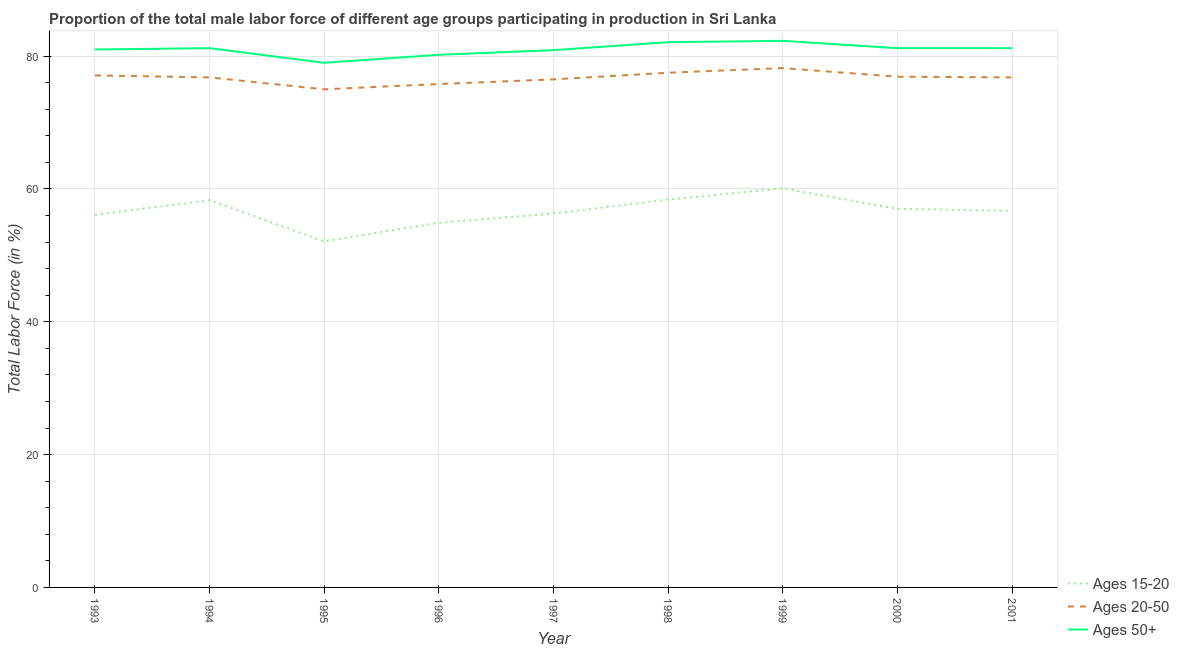Is the number of lines equal to the number of legend labels?
Give a very brief answer. Yes. What is the percentage of male labor force above age 50 in 1999?
Give a very brief answer. 82.3. Across all years, what is the maximum percentage of male labor force above age 50?
Make the answer very short. 82.3. Across all years, what is the minimum percentage of male labor force above age 50?
Offer a terse response. 79. In which year was the percentage of male labor force within the age group 20-50 minimum?
Your answer should be compact. 1995. What is the total percentage of male labor force above age 50 in the graph?
Your answer should be compact. 729.1. What is the difference between the percentage of male labor force within the age group 15-20 in 1998 and that in 2000?
Offer a terse response. 1.4. What is the difference between the percentage of male labor force within the age group 15-20 in 2001 and the percentage of male labor force above age 50 in 1993?
Provide a succinct answer. -24.3. What is the average percentage of male labor force within the age group 15-20 per year?
Your answer should be compact. 56.66. In the year 2001, what is the difference between the percentage of male labor force above age 50 and percentage of male labor force within the age group 20-50?
Make the answer very short. 4.4. In how many years, is the percentage of male labor force within the age group 15-20 greater than 20 %?
Provide a short and direct response. 9. What is the ratio of the percentage of male labor force within the age group 20-50 in 1993 to that in 1997?
Make the answer very short. 1.01. Is the difference between the percentage of male labor force within the age group 20-50 in 1998 and 2001 greater than the difference between the percentage of male labor force within the age group 15-20 in 1998 and 2001?
Make the answer very short. No. What is the difference between the highest and the second highest percentage of male labor force within the age group 15-20?
Give a very brief answer. 1.7. What is the difference between the highest and the lowest percentage of male labor force above age 50?
Make the answer very short. 3.3. Is the percentage of male labor force above age 50 strictly greater than the percentage of male labor force within the age group 20-50 over the years?
Keep it short and to the point. Yes. What is the difference between two consecutive major ticks on the Y-axis?
Give a very brief answer. 20. Are the values on the major ticks of Y-axis written in scientific E-notation?
Offer a very short reply. No. Does the graph contain any zero values?
Keep it short and to the point. No. Does the graph contain grids?
Give a very brief answer. Yes. How are the legend labels stacked?
Provide a succinct answer. Vertical. What is the title of the graph?
Provide a short and direct response. Proportion of the total male labor force of different age groups participating in production in Sri Lanka. What is the label or title of the X-axis?
Keep it short and to the point. Year. What is the label or title of the Y-axis?
Provide a succinct answer. Total Labor Force (in %). What is the Total Labor Force (in %) of Ages 15-20 in 1993?
Provide a short and direct response. 56.1. What is the Total Labor Force (in %) in Ages 20-50 in 1993?
Offer a terse response. 77.1. What is the Total Labor Force (in %) of Ages 50+ in 1993?
Offer a very short reply. 81. What is the Total Labor Force (in %) in Ages 15-20 in 1994?
Offer a very short reply. 58.3. What is the Total Labor Force (in %) of Ages 20-50 in 1994?
Offer a very short reply. 76.8. What is the Total Labor Force (in %) in Ages 50+ in 1994?
Give a very brief answer. 81.2. What is the Total Labor Force (in %) of Ages 15-20 in 1995?
Give a very brief answer. 52.1. What is the Total Labor Force (in %) of Ages 20-50 in 1995?
Provide a succinct answer. 75. What is the Total Labor Force (in %) in Ages 50+ in 1995?
Keep it short and to the point. 79. What is the Total Labor Force (in %) of Ages 15-20 in 1996?
Ensure brevity in your answer.  54.9. What is the Total Labor Force (in %) in Ages 20-50 in 1996?
Your answer should be compact. 75.8. What is the Total Labor Force (in %) in Ages 50+ in 1996?
Your answer should be compact. 80.2. What is the Total Labor Force (in %) in Ages 15-20 in 1997?
Offer a terse response. 56.3. What is the Total Labor Force (in %) of Ages 20-50 in 1997?
Keep it short and to the point. 76.5. What is the Total Labor Force (in %) in Ages 50+ in 1997?
Keep it short and to the point. 80.9. What is the Total Labor Force (in %) of Ages 15-20 in 1998?
Make the answer very short. 58.4. What is the Total Labor Force (in %) in Ages 20-50 in 1998?
Give a very brief answer. 77.5. What is the Total Labor Force (in %) of Ages 50+ in 1998?
Ensure brevity in your answer.  82.1. What is the Total Labor Force (in %) in Ages 15-20 in 1999?
Ensure brevity in your answer.  60.1. What is the Total Labor Force (in %) of Ages 20-50 in 1999?
Give a very brief answer. 78.2. What is the Total Labor Force (in %) in Ages 50+ in 1999?
Ensure brevity in your answer.  82.3. What is the Total Labor Force (in %) in Ages 15-20 in 2000?
Your response must be concise. 57. What is the Total Labor Force (in %) of Ages 20-50 in 2000?
Offer a very short reply. 76.9. What is the Total Labor Force (in %) of Ages 50+ in 2000?
Your answer should be very brief. 81.2. What is the Total Labor Force (in %) of Ages 15-20 in 2001?
Offer a terse response. 56.7. What is the Total Labor Force (in %) of Ages 20-50 in 2001?
Give a very brief answer. 76.8. What is the Total Labor Force (in %) in Ages 50+ in 2001?
Your answer should be very brief. 81.2. Across all years, what is the maximum Total Labor Force (in %) in Ages 15-20?
Make the answer very short. 60.1. Across all years, what is the maximum Total Labor Force (in %) of Ages 20-50?
Keep it short and to the point. 78.2. Across all years, what is the maximum Total Labor Force (in %) in Ages 50+?
Your response must be concise. 82.3. Across all years, what is the minimum Total Labor Force (in %) in Ages 15-20?
Offer a very short reply. 52.1. Across all years, what is the minimum Total Labor Force (in %) of Ages 20-50?
Keep it short and to the point. 75. Across all years, what is the minimum Total Labor Force (in %) in Ages 50+?
Keep it short and to the point. 79. What is the total Total Labor Force (in %) of Ages 15-20 in the graph?
Make the answer very short. 509.9. What is the total Total Labor Force (in %) of Ages 20-50 in the graph?
Offer a terse response. 690.6. What is the total Total Labor Force (in %) of Ages 50+ in the graph?
Make the answer very short. 729.1. What is the difference between the Total Labor Force (in %) of Ages 15-20 in 1993 and that in 1994?
Provide a succinct answer. -2.2. What is the difference between the Total Labor Force (in %) in Ages 20-50 in 1993 and that in 1994?
Make the answer very short. 0.3. What is the difference between the Total Labor Force (in %) of Ages 50+ in 1993 and that in 1994?
Offer a very short reply. -0.2. What is the difference between the Total Labor Force (in %) of Ages 50+ in 1993 and that in 1995?
Offer a terse response. 2. What is the difference between the Total Labor Force (in %) of Ages 15-20 in 1993 and that in 1996?
Provide a succinct answer. 1.2. What is the difference between the Total Labor Force (in %) of Ages 20-50 in 1993 and that in 1996?
Give a very brief answer. 1.3. What is the difference between the Total Labor Force (in %) of Ages 50+ in 1993 and that in 1996?
Your answer should be compact. 0.8. What is the difference between the Total Labor Force (in %) of Ages 15-20 in 1993 and that in 1997?
Make the answer very short. -0.2. What is the difference between the Total Labor Force (in %) of Ages 20-50 in 1993 and that in 1997?
Keep it short and to the point. 0.6. What is the difference between the Total Labor Force (in %) of Ages 50+ in 1993 and that in 1998?
Keep it short and to the point. -1.1. What is the difference between the Total Labor Force (in %) in Ages 50+ in 1993 and that in 1999?
Your answer should be compact. -1.3. What is the difference between the Total Labor Force (in %) of Ages 20-50 in 1993 and that in 2000?
Your response must be concise. 0.2. What is the difference between the Total Labor Force (in %) of Ages 50+ in 1993 and that in 2000?
Offer a terse response. -0.2. What is the difference between the Total Labor Force (in %) in Ages 15-20 in 1993 and that in 2001?
Offer a very short reply. -0.6. What is the difference between the Total Labor Force (in %) of Ages 20-50 in 1993 and that in 2001?
Provide a succinct answer. 0.3. What is the difference between the Total Labor Force (in %) in Ages 20-50 in 1994 and that in 1995?
Your answer should be compact. 1.8. What is the difference between the Total Labor Force (in %) in Ages 50+ in 1994 and that in 1995?
Provide a short and direct response. 2.2. What is the difference between the Total Labor Force (in %) of Ages 15-20 in 1994 and that in 1996?
Make the answer very short. 3.4. What is the difference between the Total Labor Force (in %) in Ages 50+ in 1994 and that in 1996?
Your answer should be very brief. 1. What is the difference between the Total Labor Force (in %) in Ages 15-20 in 1994 and that in 1997?
Your answer should be very brief. 2. What is the difference between the Total Labor Force (in %) of Ages 20-50 in 1994 and that in 1997?
Ensure brevity in your answer.  0.3. What is the difference between the Total Labor Force (in %) of Ages 15-20 in 1994 and that in 1998?
Your answer should be very brief. -0.1. What is the difference between the Total Labor Force (in %) in Ages 20-50 in 1994 and that in 1998?
Offer a very short reply. -0.7. What is the difference between the Total Labor Force (in %) in Ages 50+ in 1994 and that in 1998?
Keep it short and to the point. -0.9. What is the difference between the Total Labor Force (in %) of Ages 50+ in 1994 and that in 1999?
Offer a terse response. -1.1. What is the difference between the Total Labor Force (in %) of Ages 20-50 in 1994 and that in 2000?
Your answer should be compact. -0.1. What is the difference between the Total Labor Force (in %) of Ages 50+ in 1994 and that in 2000?
Offer a terse response. 0. What is the difference between the Total Labor Force (in %) of Ages 20-50 in 1994 and that in 2001?
Offer a terse response. 0. What is the difference between the Total Labor Force (in %) of Ages 50+ in 1994 and that in 2001?
Ensure brevity in your answer.  0. What is the difference between the Total Labor Force (in %) in Ages 20-50 in 1995 and that in 1996?
Your answer should be very brief. -0.8. What is the difference between the Total Labor Force (in %) in Ages 50+ in 1995 and that in 1996?
Your answer should be very brief. -1.2. What is the difference between the Total Labor Force (in %) of Ages 15-20 in 1995 and that in 1997?
Provide a short and direct response. -4.2. What is the difference between the Total Labor Force (in %) in Ages 50+ in 1995 and that in 1997?
Offer a terse response. -1.9. What is the difference between the Total Labor Force (in %) in Ages 15-20 in 1995 and that in 1998?
Offer a terse response. -6.3. What is the difference between the Total Labor Force (in %) of Ages 50+ in 1995 and that in 1998?
Your answer should be very brief. -3.1. What is the difference between the Total Labor Force (in %) in Ages 15-20 in 1995 and that in 1999?
Give a very brief answer. -8. What is the difference between the Total Labor Force (in %) of Ages 20-50 in 1995 and that in 1999?
Make the answer very short. -3.2. What is the difference between the Total Labor Force (in %) of Ages 50+ in 1995 and that in 1999?
Offer a very short reply. -3.3. What is the difference between the Total Labor Force (in %) in Ages 15-20 in 1995 and that in 2000?
Ensure brevity in your answer.  -4.9. What is the difference between the Total Labor Force (in %) in Ages 20-50 in 1995 and that in 2000?
Make the answer very short. -1.9. What is the difference between the Total Labor Force (in %) in Ages 20-50 in 1995 and that in 2001?
Ensure brevity in your answer.  -1.8. What is the difference between the Total Labor Force (in %) in Ages 50+ in 1995 and that in 2001?
Provide a short and direct response. -2.2. What is the difference between the Total Labor Force (in %) of Ages 15-20 in 1996 and that in 1997?
Your answer should be compact. -1.4. What is the difference between the Total Labor Force (in %) in Ages 50+ in 1996 and that in 1997?
Provide a short and direct response. -0.7. What is the difference between the Total Labor Force (in %) of Ages 15-20 in 1996 and that in 1998?
Offer a terse response. -3.5. What is the difference between the Total Labor Force (in %) in Ages 20-50 in 1996 and that in 1998?
Your answer should be compact. -1.7. What is the difference between the Total Labor Force (in %) in Ages 20-50 in 1996 and that in 1999?
Provide a short and direct response. -2.4. What is the difference between the Total Labor Force (in %) of Ages 15-20 in 1996 and that in 2000?
Provide a short and direct response. -2.1. What is the difference between the Total Labor Force (in %) in Ages 15-20 in 1996 and that in 2001?
Your response must be concise. -1.8. What is the difference between the Total Labor Force (in %) of Ages 50+ in 1996 and that in 2001?
Provide a short and direct response. -1. What is the difference between the Total Labor Force (in %) in Ages 50+ in 1997 and that in 1998?
Ensure brevity in your answer.  -1.2. What is the difference between the Total Labor Force (in %) of Ages 20-50 in 1997 and that in 1999?
Your answer should be compact. -1.7. What is the difference between the Total Labor Force (in %) of Ages 50+ in 1997 and that in 1999?
Ensure brevity in your answer.  -1.4. What is the difference between the Total Labor Force (in %) in Ages 20-50 in 1998 and that in 1999?
Your answer should be compact. -0.7. What is the difference between the Total Labor Force (in %) of Ages 50+ in 1998 and that in 2000?
Offer a very short reply. 0.9. What is the difference between the Total Labor Force (in %) in Ages 15-20 in 1998 and that in 2001?
Provide a succinct answer. 1.7. What is the difference between the Total Labor Force (in %) in Ages 20-50 in 1998 and that in 2001?
Offer a very short reply. 0.7. What is the difference between the Total Labor Force (in %) in Ages 50+ in 1998 and that in 2001?
Your response must be concise. 0.9. What is the difference between the Total Labor Force (in %) in Ages 15-20 in 1999 and that in 2000?
Your answer should be very brief. 3.1. What is the difference between the Total Labor Force (in %) of Ages 20-50 in 1999 and that in 2000?
Your answer should be very brief. 1.3. What is the difference between the Total Labor Force (in %) in Ages 15-20 in 1999 and that in 2001?
Keep it short and to the point. 3.4. What is the difference between the Total Labor Force (in %) of Ages 50+ in 1999 and that in 2001?
Your answer should be very brief. 1.1. What is the difference between the Total Labor Force (in %) in Ages 15-20 in 2000 and that in 2001?
Ensure brevity in your answer.  0.3. What is the difference between the Total Labor Force (in %) in Ages 15-20 in 1993 and the Total Labor Force (in %) in Ages 20-50 in 1994?
Provide a succinct answer. -20.7. What is the difference between the Total Labor Force (in %) in Ages 15-20 in 1993 and the Total Labor Force (in %) in Ages 50+ in 1994?
Your response must be concise. -25.1. What is the difference between the Total Labor Force (in %) in Ages 20-50 in 1993 and the Total Labor Force (in %) in Ages 50+ in 1994?
Your response must be concise. -4.1. What is the difference between the Total Labor Force (in %) of Ages 15-20 in 1993 and the Total Labor Force (in %) of Ages 20-50 in 1995?
Your answer should be compact. -18.9. What is the difference between the Total Labor Force (in %) in Ages 15-20 in 1993 and the Total Labor Force (in %) in Ages 50+ in 1995?
Keep it short and to the point. -22.9. What is the difference between the Total Labor Force (in %) of Ages 20-50 in 1993 and the Total Labor Force (in %) of Ages 50+ in 1995?
Your answer should be compact. -1.9. What is the difference between the Total Labor Force (in %) in Ages 15-20 in 1993 and the Total Labor Force (in %) in Ages 20-50 in 1996?
Your answer should be very brief. -19.7. What is the difference between the Total Labor Force (in %) of Ages 15-20 in 1993 and the Total Labor Force (in %) of Ages 50+ in 1996?
Offer a terse response. -24.1. What is the difference between the Total Labor Force (in %) in Ages 15-20 in 1993 and the Total Labor Force (in %) in Ages 20-50 in 1997?
Provide a succinct answer. -20.4. What is the difference between the Total Labor Force (in %) in Ages 15-20 in 1993 and the Total Labor Force (in %) in Ages 50+ in 1997?
Provide a succinct answer. -24.8. What is the difference between the Total Labor Force (in %) of Ages 20-50 in 1993 and the Total Labor Force (in %) of Ages 50+ in 1997?
Offer a terse response. -3.8. What is the difference between the Total Labor Force (in %) in Ages 15-20 in 1993 and the Total Labor Force (in %) in Ages 20-50 in 1998?
Provide a short and direct response. -21.4. What is the difference between the Total Labor Force (in %) in Ages 20-50 in 1993 and the Total Labor Force (in %) in Ages 50+ in 1998?
Your answer should be compact. -5. What is the difference between the Total Labor Force (in %) of Ages 15-20 in 1993 and the Total Labor Force (in %) of Ages 20-50 in 1999?
Provide a succinct answer. -22.1. What is the difference between the Total Labor Force (in %) in Ages 15-20 in 1993 and the Total Labor Force (in %) in Ages 50+ in 1999?
Keep it short and to the point. -26.2. What is the difference between the Total Labor Force (in %) in Ages 15-20 in 1993 and the Total Labor Force (in %) in Ages 20-50 in 2000?
Ensure brevity in your answer.  -20.8. What is the difference between the Total Labor Force (in %) in Ages 15-20 in 1993 and the Total Labor Force (in %) in Ages 50+ in 2000?
Offer a terse response. -25.1. What is the difference between the Total Labor Force (in %) in Ages 20-50 in 1993 and the Total Labor Force (in %) in Ages 50+ in 2000?
Keep it short and to the point. -4.1. What is the difference between the Total Labor Force (in %) in Ages 15-20 in 1993 and the Total Labor Force (in %) in Ages 20-50 in 2001?
Your response must be concise. -20.7. What is the difference between the Total Labor Force (in %) in Ages 15-20 in 1993 and the Total Labor Force (in %) in Ages 50+ in 2001?
Offer a terse response. -25.1. What is the difference between the Total Labor Force (in %) in Ages 20-50 in 1993 and the Total Labor Force (in %) in Ages 50+ in 2001?
Your response must be concise. -4.1. What is the difference between the Total Labor Force (in %) of Ages 15-20 in 1994 and the Total Labor Force (in %) of Ages 20-50 in 1995?
Give a very brief answer. -16.7. What is the difference between the Total Labor Force (in %) in Ages 15-20 in 1994 and the Total Labor Force (in %) in Ages 50+ in 1995?
Provide a short and direct response. -20.7. What is the difference between the Total Labor Force (in %) in Ages 20-50 in 1994 and the Total Labor Force (in %) in Ages 50+ in 1995?
Offer a terse response. -2.2. What is the difference between the Total Labor Force (in %) in Ages 15-20 in 1994 and the Total Labor Force (in %) in Ages 20-50 in 1996?
Provide a succinct answer. -17.5. What is the difference between the Total Labor Force (in %) of Ages 15-20 in 1994 and the Total Labor Force (in %) of Ages 50+ in 1996?
Ensure brevity in your answer.  -21.9. What is the difference between the Total Labor Force (in %) in Ages 15-20 in 1994 and the Total Labor Force (in %) in Ages 20-50 in 1997?
Keep it short and to the point. -18.2. What is the difference between the Total Labor Force (in %) in Ages 15-20 in 1994 and the Total Labor Force (in %) in Ages 50+ in 1997?
Give a very brief answer. -22.6. What is the difference between the Total Labor Force (in %) of Ages 15-20 in 1994 and the Total Labor Force (in %) of Ages 20-50 in 1998?
Ensure brevity in your answer.  -19.2. What is the difference between the Total Labor Force (in %) of Ages 15-20 in 1994 and the Total Labor Force (in %) of Ages 50+ in 1998?
Offer a very short reply. -23.8. What is the difference between the Total Labor Force (in %) of Ages 15-20 in 1994 and the Total Labor Force (in %) of Ages 20-50 in 1999?
Give a very brief answer. -19.9. What is the difference between the Total Labor Force (in %) in Ages 15-20 in 1994 and the Total Labor Force (in %) in Ages 50+ in 1999?
Give a very brief answer. -24. What is the difference between the Total Labor Force (in %) of Ages 20-50 in 1994 and the Total Labor Force (in %) of Ages 50+ in 1999?
Offer a very short reply. -5.5. What is the difference between the Total Labor Force (in %) of Ages 15-20 in 1994 and the Total Labor Force (in %) of Ages 20-50 in 2000?
Offer a very short reply. -18.6. What is the difference between the Total Labor Force (in %) in Ages 15-20 in 1994 and the Total Labor Force (in %) in Ages 50+ in 2000?
Keep it short and to the point. -22.9. What is the difference between the Total Labor Force (in %) of Ages 15-20 in 1994 and the Total Labor Force (in %) of Ages 20-50 in 2001?
Keep it short and to the point. -18.5. What is the difference between the Total Labor Force (in %) in Ages 15-20 in 1994 and the Total Labor Force (in %) in Ages 50+ in 2001?
Offer a terse response. -22.9. What is the difference between the Total Labor Force (in %) in Ages 15-20 in 1995 and the Total Labor Force (in %) in Ages 20-50 in 1996?
Offer a very short reply. -23.7. What is the difference between the Total Labor Force (in %) in Ages 15-20 in 1995 and the Total Labor Force (in %) in Ages 50+ in 1996?
Your answer should be compact. -28.1. What is the difference between the Total Labor Force (in %) of Ages 15-20 in 1995 and the Total Labor Force (in %) of Ages 20-50 in 1997?
Your answer should be compact. -24.4. What is the difference between the Total Labor Force (in %) of Ages 15-20 in 1995 and the Total Labor Force (in %) of Ages 50+ in 1997?
Offer a terse response. -28.8. What is the difference between the Total Labor Force (in %) of Ages 15-20 in 1995 and the Total Labor Force (in %) of Ages 20-50 in 1998?
Your answer should be very brief. -25.4. What is the difference between the Total Labor Force (in %) in Ages 20-50 in 1995 and the Total Labor Force (in %) in Ages 50+ in 1998?
Your answer should be compact. -7.1. What is the difference between the Total Labor Force (in %) of Ages 15-20 in 1995 and the Total Labor Force (in %) of Ages 20-50 in 1999?
Offer a very short reply. -26.1. What is the difference between the Total Labor Force (in %) of Ages 15-20 in 1995 and the Total Labor Force (in %) of Ages 50+ in 1999?
Make the answer very short. -30.2. What is the difference between the Total Labor Force (in %) of Ages 15-20 in 1995 and the Total Labor Force (in %) of Ages 20-50 in 2000?
Offer a very short reply. -24.8. What is the difference between the Total Labor Force (in %) of Ages 15-20 in 1995 and the Total Labor Force (in %) of Ages 50+ in 2000?
Provide a succinct answer. -29.1. What is the difference between the Total Labor Force (in %) in Ages 20-50 in 1995 and the Total Labor Force (in %) in Ages 50+ in 2000?
Your answer should be very brief. -6.2. What is the difference between the Total Labor Force (in %) of Ages 15-20 in 1995 and the Total Labor Force (in %) of Ages 20-50 in 2001?
Give a very brief answer. -24.7. What is the difference between the Total Labor Force (in %) of Ages 15-20 in 1995 and the Total Labor Force (in %) of Ages 50+ in 2001?
Keep it short and to the point. -29.1. What is the difference between the Total Labor Force (in %) in Ages 15-20 in 1996 and the Total Labor Force (in %) in Ages 20-50 in 1997?
Your response must be concise. -21.6. What is the difference between the Total Labor Force (in %) of Ages 20-50 in 1996 and the Total Labor Force (in %) of Ages 50+ in 1997?
Make the answer very short. -5.1. What is the difference between the Total Labor Force (in %) of Ages 15-20 in 1996 and the Total Labor Force (in %) of Ages 20-50 in 1998?
Offer a very short reply. -22.6. What is the difference between the Total Labor Force (in %) in Ages 15-20 in 1996 and the Total Labor Force (in %) in Ages 50+ in 1998?
Your answer should be very brief. -27.2. What is the difference between the Total Labor Force (in %) in Ages 20-50 in 1996 and the Total Labor Force (in %) in Ages 50+ in 1998?
Your response must be concise. -6.3. What is the difference between the Total Labor Force (in %) of Ages 15-20 in 1996 and the Total Labor Force (in %) of Ages 20-50 in 1999?
Keep it short and to the point. -23.3. What is the difference between the Total Labor Force (in %) of Ages 15-20 in 1996 and the Total Labor Force (in %) of Ages 50+ in 1999?
Offer a terse response. -27.4. What is the difference between the Total Labor Force (in %) of Ages 15-20 in 1996 and the Total Labor Force (in %) of Ages 20-50 in 2000?
Offer a terse response. -22. What is the difference between the Total Labor Force (in %) of Ages 15-20 in 1996 and the Total Labor Force (in %) of Ages 50+ in 2000?
Ensure brevity in your answer.  -26.3. What is the difference between the Total Labor Force (in %) in Ages 20-50 in 1996 and the Total Labor Force (in %) in Ages 50+ in 2000?
Your answer should be very brief. -5.4. What is the difference between the Total Labor Force (in %) in Ages 15-20 in 1996 and the Total Labor Force (in %) in Ages 20-50 in 2001?
Ensure brevity in your answer.  -21.9. What is the difference between the Total Labor Force (in %) of Ages 15-20 in 1996 and the Total Labor Force (in %) of Ages 50+ in 2001?
Keep it short and to the point. -26.3. What is the difference between the Total Labor Force (in %) in Ages 15-20 in 1997 and the Total Labor Force (in %) in Ages 20-50 in 1998?
Keep it short and to the point. -21.2. What is the difference between the Total Labor Force (in %) in Ages 15-20 in 1997 and the Total Labor Force (in %) in Ages 50+ in 1998?
Your answer should be very brief. -25.8. What is the difference between the Total Labor Force (in %) of Ages 15-20 in 1997 and the Total Labor Force (in %) of Ages 20-50 in 1999?
Your answer should be very brief. -21.9. What is the difference between the Total Labor Force (in %) of Ages 15-20 in 1997 and the Total Labor Force (in %) of Ages 50+ in 1999?
Ensure brevity in your answer.  -26. What is the difference between the Total Labor Force (in %) of Ages 15-20 in 1997 and the Total Labor Force (in %) of Ages 20-50 in 2000?
Give a very brief answer. -20.6. What is the difference between the Total Labor Force (in %) of Ages 15-20 in 1997 and the Total Labor Force (in %) of Ages 50+ in 2000?
Keep it short and to the point. -24.9. What is the difference between the Total Labor Force (in %) of Ages 15-20 in 1997 and the Total Labor Force (in %) of Ages 20-50 in 2001?
Your answer should be very brief. -20.5. What is the difference between the Total Labor Force (in %) of Ages 15-20 in 1997 and the Total Labor Force (in %) of Ages 50+ in 2001?
Your answer should be compact. -24.9. What is the difference between the Total Labor Force (in %) of Ages 15-20 in 1998 and the Total Labor Force (in %) of Ages 20-50 in 1999?
Make the answer very short. -19.8. What is the difference between the Total Labor Force (in %) in Ages 15-20 in 1998 and the Total Labor Force (in %) in Ages 50+ in 1999?
Ensure brevity in your answer.  -23.9. What is the difference between the Total Labor Force (in %) in Ages 20-50 in 1998 and the Total Labor Force (in %) in Ages 50+ in 1999?
Provide a short and direct response. -4.8. What is the difference between the Total Labor Force (in %) of Ages 15-20 in 1998 and the Total Labor Force (in %) of Ages 20-50 in 2000?
Ensure brevity in your answer.  -18.5. What is the difference between the Total Labor Force (in %) in Ages 15-20 in 1998 and the Total Labor Force (in %) in Ages 50+ in 2000?
Provide a short and direct response. -22.8. What is the difference between the Total Labor Force (in %) of Ages 20-50 in 1998 and the Total Labor Force (in %) of Ages 50+ in 2000?
Your answer should be very brief. -3.7. What is the difference between the Total Labor Force (in %) in Ages 15-20 in 1998 and the Total Labor Force (in %) in Ages 20-50 in 2001?
Keep it short and to the point. -18.4. What is the difference between the Total Labor Force (in %) in Ages 15-20 in 1998 and the Total Labor Force (in %) in Ages 50+ in 2001?
Your answer should be compact. -22.8. What is the difference between the Total Labor Force (in %) of Ages 20-50 in 1998 and the Total Labor Force (in %) of Ages 50+ in 2001?
Make the answer very short. -3.7. What is the difference between the Total Labor Force (in %) in Ages 15-20 in 1999 and the Total Labor Force (in %) in Ages 20-50 in 2000?
Give a very brief answer. -16.8. What is the difference between the Total Labor Force (in %) of Ages 15-20 in 1999 and the Total Labor Force (in %) of Ages 50+ in 2000?
Keep it short and to the point. -21.1. What is the difference between the Total Labor Force (in %) in Ages 20-50 in 1999 and the Total Labor Force (in %) in Ages 50+ in 2000?
Your answer should be compact. -3. What is the difference between the Total Labor Force (in %) in Ages 15-20 in 1999 and the Total Labor Force (in %) in Ages 20-50 in 2001?
Make the answer very short. -16.7. What is the difference between the Total Labor Force (in %) of Ages 15-20 in 1999 and the Total Labor Force (in %) of Ages 50+ in 2001?
Keep it short and to the point. -21.1. What is the difference between the Total Labor Force (in %) in Ages 20-50 in 1999 and the Total Labor Force (in %) in Ages 50+ in 2001?
Give a very brief answer. -3. What is the difference between the Total Labor Force (in %) of Ages 15-20 in 2000 and the Total Labor Force (in %) of Ages 20-50 in 2001?
Your answer should be compact. -19.8. What is the difference between the Total Labor Force (in %) of Ages 15-20 in 2000 and the Total Labor Force (in %) of Ages 50+ in 2001?
Your response must be concise. -24.2. What is the average Total Labor Force (in %) in Ages 15-20 per year?
Keep it short and to the point. 56.66. What is the average Total Labor Force (in %) of Ages 20-50 per year?
Your response must be concise. 76.73. What is the average Total Labor Force (in %) in Ages 50+ per year?
Keep it short and to the point. 81.01. In the year 1993, what is the difference between the Total Labor Force (in %) of Ages 15-20 and Total Labor Force (in %) of Ages 20-50?
Your answer should be compact. -21. In the year 1993, what is the difference between the Total Labor Force (in %) of Ages 15-20 and Total Labor Force (in %) of Ages 50+?
Offer a very short reply. -24.9. In the year 1993, what is the difference between the Total Labor Force (in %) in Ages 20-50 and Total Labor Force (in %) in Ages 50+?
Offer a very short reply. -3.9. In the year 1994, what is the difference between the Total Labor Force (in %) in Ages 15-20 and Total Labor Force (in %) in Ages 20-50?
Offer a terse response. -18.5. In the year 1994, what is the difference between the Total Labor Force (in %) in Ages 15-20 and Total Labor Force (in %) in Ages 50+?
Your answer should be very brief. -22.9. In the year 1994, what is the difference between the Total Labor Force (in %) of Ages 20-50 and Total Labor Force (in %) of Ages 50+?
Your answer should be compact. -4.4. In the year 1995, what is the difference between the Total Labor Force (in %) of Ages 15-20 and Total Labor Force (in %) of Ages 20-50?
Keep it short and to the point. -22.9. In the year 1995, what is the difference between the Total Labor Force (in %) in Ages 15-20 and Total Labor Force (in %) in Ages 50+?
Your response must be concise. -26.9. In the year 1996, what is the difference between the Total Labor Force (in %) of Ages 15-20 and Total Labor Force (in %) of Ages 20-50?
Provide a succinct answer. -20.9. In the year 1996, what is the difference between the Total Labor Force (in %) of Ages 15-20 and Total Labor Force (in %) of Ages 50+?
Your answer should be compact. -25.3. In the year 1997, what is the difference between the Total Labor Force (in %) in Ages 15-20 and Total Labor Force (in %) in Ages 20-50?
Provide a short and direct response. -20.2. In the year 1997, what is the difference between the Total Labor Force (in %) of Ages 15-20 and Total Labor Force (in %) of Ages 50+?
Your answer should be very brief. -24.6. In the year 1997, what is the difference between the Total Labor Force (in %) of Ages 20-50 and Total Labor Force (in %) of Ages 50+?
Your response must be concise. -4.4. In the year 1998, what is the difference between the Total Labor Force (in %) in Ages 15-20 and Total Labor Force (in %) in Ages 20-50?
Ensure brevity in your answer.  -19.1. In the year 1998, what is the difference between the Total Labor Force (in %) in Ages 15-20 and Total Labor Force (in %) in Ages 50+?
Provide a short and direct response. -23.7. In the year 1998, what is the difference between the Total Labor Force (in %) in Ages 20-50 and Total Labor Force (in %) in Ages 50+?
Ensure brevity in your answer.  -4.6. In the year 1999, what is the difference between the Total Labor Force (in %) of Ages 15-20 and Total Labor Force (in %) of Ages 20-50?
Provide a short and direct response. -18.1. In the year 1999, what is the difference between the Total Labor Force (in %) in Ages 15-20 and Total Labor Force (in %) in Ages 50+?
Your answer should be compact. -22.2. In the year 1999, what is the difference between the Total Labor Force (in %) in Ages 20-50 and Total Labor Force (in %) in Ages 50+?
Give a very brief answer. -4.1. In the year 2000, what is the difference between the Total Labor Force (in %) of Ages 15-20 and Total Labor Force (in %) of Ages 20-50?
Provide a short and direct response. -19.9. In the year 2000, what is the difference between the Total Labor Force (in %) of Ages 15-20 and Total Labor Force (in %) of Ages 50+?
Your response must be concise. -24.2. In the year 2001, what is the difference between the Total Labor Force (in %) in Ages 15-20 and Total Labor Force (in %) in Ages 20-50?
Offer a terse response. -20.1. In the year 2001, what is the difference between the Total Labor Force (in %) in Ages 15-20 and Total Labor Force (in %) in Ages 50+?
Provide a succinct answer. -24.5. What is the ratio of the Total Labor Force (in %) in Ages 15-20 in 1993 to that in 1994?
Offer a very short reply. 0.96. What is the ratio of the Total Labor Force (in %) of Ages 50+ in 1993 to that in 1994?
Offer a terse response. 1. What is the ratio of the Total Labor Force (in %) of Ages 15-20 in 1993 to that in 1995?
Offer a terse response. 1.08. What is the ratio of the Total Labor Force (in %) in Ages 20-50 in 1993 to that in 1995?
Provide a succinct answer. 1.03. What is the ratio of the Total Labor Force (in %) in Ages 50+ in 1993 to that in 1995?
Keep it short and to the point. 1.03. What is the ratio of the Total Labor Force (in %) of Ages 15-20 in 1993 to that in 1996?
Keep it short and to the point. 1.02. What is the ratio of the Total Labor Force (in %) in Ages 20-50 in 1993 to that in 1996?
Give a very brief answer. 1.02. What is the ratio of the Total Labor Force (in %) of Ages 50+ in 1993 to that in 1997?
Offer a very short reply. 1. What is the ratio of the Total Labor Force (in %) in Ages 15-20 in 1993 to that in 1998?
Ensure brevity in your answer.  0.96. What is the ratio of the Total Labor Force (in %) in Ages 20-50 in 1993 to that in 1998?
Your answer should be very brief. 0.99. What is the ratio of the Total Labor Force (in %) of Ages 50+ in 1993 to that in 1998?
Your response must be concise. 0.99. What is the ratio of the Total Labor Force (in %) of Ages 15-20 in 1993 to that in 1999?
Offer a very short reply. 0.93. What is the ratio of the Total Labor Force (in %) of Ages 20-50 in 1993 to that in 1999?
Keep it short and to the point. 0.99. What is the ratio of the Total Labor Force (in %) in Ages 50+ in 1993 to that in 1999?
Keep it short and to the point. 0.98. What is the ratio of the Total Labor Force (in %) in Ages 15-20 in 1993 to that in 2000?
Your answer should be compact. 0.98. What is the ratio of the Total Labor Force (in %) of Ages 20-50 in 1993 to that in 2000?
Your answer should be compact. 1. What is the ratio of the Total Labor Force (in %) in Ages 50+ in 1993 to that in 2000?
Your response must be concise. 1. What is the ratio of the Total Labor Force (in %) of Ages 15-20 in 1994 to that in 1995?
Give a very brief answer. 1.12. What is the ratio of the Total Labor Force (in %) in Ages 50+ in 1994 to that in 1995?
Your answer should be very brief. 1.03. What is the ratio of the Total Labor Force (in %) in Ages 15-20 in 1994 to that in 1996?
Keep it short and to the point. 1.06. What is the ratio of the Total Labor Force (in %) of Ages 20-50 in 1994 to that in 1996?
Your response must be concise. 1.01. What is the ratio of the Total Labor Force (in %) of Ages 50+ in 1994 to that in 1996?
Provide a succinct answer. 1.01. What is the ratio of the Total Labor Force (in %) of Ages 15-20 in 1994 to that in 1997?
Ensure brevity in your answer.  1.04. What is the ratio of the Total Labor Force (in %) of Ages 20-50 in 1994 to that in 1997?
Make the answer very short. 1. What is the ratio of the Total Labor Force (in %) in Ages 15-20 in 1994 to that in 1999?
Make the answer very short. 0.97. What is the ratio of the Total Labor Force (in %) in Ages 20-50 in 1994 to that in 1999?
Make the answer very short. 0.98. What is the ratio of the Total Labor Force (in %) in Ages 50+ in 1994 to that in 1999?
Give a very brief answer. 0.99. What is the ratio of the Total Labor Force (in %) in Ages 15-20 in 1994 to that in 2000?
Provide a short and direct response. 1.02. What is the ratio of the Total Labor Force (in %) in Ages 50+ in 1994 to that in 2000?
Make the answer very short. 1. What is the ratio of the Total Labor Force (in %) of Ages 15-20 in 1994 to that in 2001?
Provide a succinct answer. 1.03. What is the ratio of the Total Labor Force (in %) in Ages 20-50 in 1994 to that in 2001?
Make the answer very short. 1. What is the ratio of the Total Labor Force (in %) of Ages 50+ in 1994 to that in 2001?
Give a very brief answer. 1. What is the ratio of the Total Labor Force (in %) in Ages 15-20 in 1995 to that in 1996?
Provide a short and direct response. 0.95. What is the ratio of the Total Labor Force (in %) of Ages 20-50 in 1995 to that in 1996?
Your response must be concise. 0.99. What is the ratio of the Total Labor Force (in %) of Ages 15-20 in 1995 to that in 1997?
Offer a terse response. 0.93. What is the ratio of the Total Labor Force (in %) in Ages 20-50 in 1995 to that in 1997?
Give a very brief answer. 0.98. What is the ratio of the Total Labor Force (in %) of Ages 50+ in 1995 to that in 1997?
Give a very brief answer. 0.98. What is the ratio of the Total Labor Force (in %) of Ages 15-20 in 1995 to that in 1998?
Provide a succinct answer. 0.89. What is the ratio of the Total Labor Force (in %) of Ages 50+ in 1995 to that in 1998?
Offer a very short reply. 0.96. What is the ratio of the Total Labor Force (in %) of Ages 15-20 in 1995 to that in 1999?
Your response must be concise. 0.87. What is the ratio of the Total Labor Force (in %) in Ages 20-50 in 1995 to that in 1999?
Give a very brief answer. 0.96. What is the ratio of the Total Labor Force (in %) of Ages 50+ in 1995 to that in 1999?
Provide a succinct answer. 0.96. What is the ratio of the Total Labor Force (in %) in Ages 15-20 in 1995 to that in 2000?
Keep it short and to the point. 0.91. What is the ratio of the Total Labor Force (in %) in Ages 20-50 in 1995 to that in 2000?
Provide a succinct answer. 0.98. What is the ratio of the Total Labor Force (in %) in Ages 50+ in 1995 to that in 2000?
Offer a terse response. 0.97. What is the ratio of the Total Labor Force (in %) of Ages 15-20 in 1995 to that in 2001?
Offer a terse response. 0.92. What is the ratio of the Total Labor Force (in %) of Ages 20-50 in 1995 to that in 2001?
Your answer should be very brief. 0.98. What is the ratio of the Total Labor Force (in %) in Ages 50+ in 1995 to that in 2001?
Give a very brief answer. 0.97. What is the ratio of the Total Labor Force (in %) of Ages 15-20 in 1996 to that in 1997?
Ensure brevity in your answer.  0.98. What is the ratio of the Total Labor Force (in %) in Ages 50+ in 1996 to that in 1997?
Your answer should be compact. 0.99. What is the ratio of the Total Labor Force (in %) in Ages 15-20 in 1996 to that in 1998?
Provide a short and direct response. 0.94. What is the ratio of the Total Labor Force (in %) of Ages 20-50 in 1996 to that in 1998?
Ensure brevity in your answer.  0.98. What is the ratio of the Total Labor Force (in %) in Ages 50+ in 1996 to that in 1998?
Your response must be concise. 0.98. What is the ratio of the Total Labor Force (in %) of Ages 15-20 in 1996 to that in 1999?
Keep it short and to the point. 0.91. What is the ratio of the Total Labor Force (in %) in Ages 20-50 in 1996 to that in 1999?
Give a very brief answer. 0.97. What is the ratio of the Total Labor Force (in %) in Ages 50+ in 1996 to that in 1999?
Your answer should be very brief. 0.97. What is the ratio of the Total Labor Force (in %) in Ages 15-20 in 1996 to that in 2000?
Your answer should be very brief. 0.96. What is the ratio of the Total Labor Force (in %) of Ages 20-50 in 1996 to that in 2000?
Offer a terse response. 0.99. What is the ratio of the Total Labor Force (in %) of Ages 50+ in 1996 to that in 2000?
Provide a short and direct response. 0.99. What is the ratio of the Total Labor Force (in %) of Ages 15-20 in 1996 to that in 2001?
Give a very brief answer. 0.97. What is the ratio of the Total Labor Force (in %) in Ages 50+ in 1996 to that in 2001?
Keep it short and to the point. 0.99. What is the ratio of the Total Labor Force (in %) of Ages 20-50 in 1997 to that in 1998?
Your answer should be very brief. 0.99. What is the ratio of the Total Labor Force (in %) of Ages 50+ in 1997 to that in 1998?
Offer a terse response. 0.99. What is the ratio of the Total Labor Force (in %) of Ages 15-20 in 1997 to that in 1999?
Give a very brief answer. 0.94. What is the ratio of the Total Labor Force (in %) of Ages 20-50 in 1997 to that in 1999?
Offer a very short reply. 0.98. What is the ratio of the Total Labor Force (in %) in Ages 20-50 in 1997 to that in 2000?
Give a very brief answer. 0.99. What is the ratio of the Total Labor Force (in %) of Ages 20-50 in 1997 to that in 2001?
Provide a short and direct response. 1. What is the ratio of the Total Labor Force (in %) of Ages 50+ in 1997 to that in 2001?
Make the answer very short. 1. What is the ratio of the Total Labor Force (in %) in Ages 15-20 in 1998 to that in 1999?
Your answer should be very brief. 0.97. What is the ratio of the Total Labor Force (in %) in Ages 20-50 in 1998 to that in 1999?
Offer a very short reply. 0.99. What is the ratio of the Total Labor Force (in %) in Ages 15-20 in 1998 to that in 2000?
Your response must be concise. 1.02. What is the ratio of the Total Labor Force (in %) in Ages 20-50 in 1998 to that in 2000?
Offer a very short reply. 1.01. What is the ratio of the Total Labor Force (in %) of Ages 50+ in 1998 to that in 2000?
Give a very brief answer. 1.01. What is the ratio of the Total Labor Force (in %) in Ages 20-50 in 1998 to that in 2001?
Your answer should be compact. 1.01. What is the ratio of the Total Labor Force (in %) of Ages 50+ in 1998 to that in 2001?
Keep it short and to the point. 1.01. What is the ratio of the Total Labor Force (in %) in Ages 15-20 in 1999 to that in 2000?
Make the answer very short. 1.05. What is the ratio of the Total Labor Force (in %) in Ages 20-50 in 1999 to that in 2000?
Make the answer very short. 1.02. What is the ratio of the Total Labor Force (in %) of Ages 50+ in 1999 to that in 2000?
Your answer should be very brief. 1.01. What is the ratio of the Total Labor Force (in %) of Ages 15-20 in 1999 to that in 2001?
Provide a short and direct response. 1.06. What is the ratio of the Total Labor Force (in %) of Ages 20-50 in 1999 to that in 2001?
Your response must be concise. 1.02. What is the ratio of the Total Labor Force (in %) in Ages 50+ in 1999 to that in 2001?
Your answer should be compact. 1.01. What is the ratio of the Total Labor Force (in %) of Ages 15-20 in 2000 to that in 2001?
Your answer should be compact. 1.01. What is the ratio of the Total Labor Force (in %) of Ages 20-50 in 2000 to that in 2001?
Ensure brevity in your answer.  1. What is the ratio of the Total Labor Force (in %) of Ages 50+ in 2000 to that in 2001?
Your response must be concise. 1. What is the difference between the highest and the second highest Total Labor Force (in %) in Ages 15-20?
Make the answer very short. 1.7. What is the difference between the highest and the second highest Total Labor Force (in %) of Ages 20-50?
Offer a terse response. 0.7. 